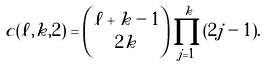Convert formula to latex. <formula><loc_0><loc_0><loc_500><loc_500>c ( \ell , k , 2 ) & = \binom { \ell + k - 1 } { 2 k } \prod _ { j = 1 } ^ { k } ( 2 j - 1 ) .</formula> 